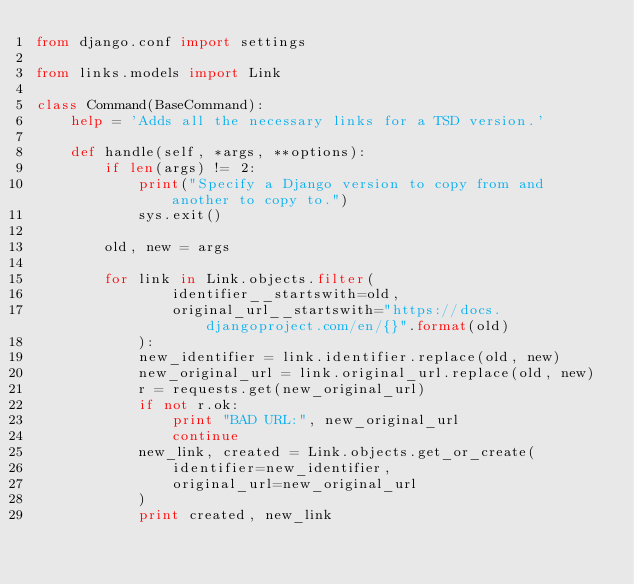Convert code to text. <code><loc_0><loc_0><loc_500><loc_500><_Python_>from django.conf import settings

from links.models import Link

class Command(BaseCommand):
    help = 'Adds all the necessary links for a TSD version.'

    def handle(self, *args, **options):
        if len(args) != 2:
            print("Specify a Django version to copy from and another to copy to.")
            sys.exit()

        old, new = args

        for link in Link.objects.filter(
                identifier__startswith=old,
                original_url__startswith="https://docs.djangoproject.com/en/{}".format(old)
            ):
            new_identifier = link.identifier.replace(old, new)
            new_original_url = link.original_url.replace(old, new)
            r = requests.get(new_original_url)
            if not r.ok:
                print "BAD URL:", new_original_url
                continue
            new_link, created = Link.objects.get_or_create(
                identifier=new_identifier,
                original_url=new_original_url
            )
            print created, new_link</code> 